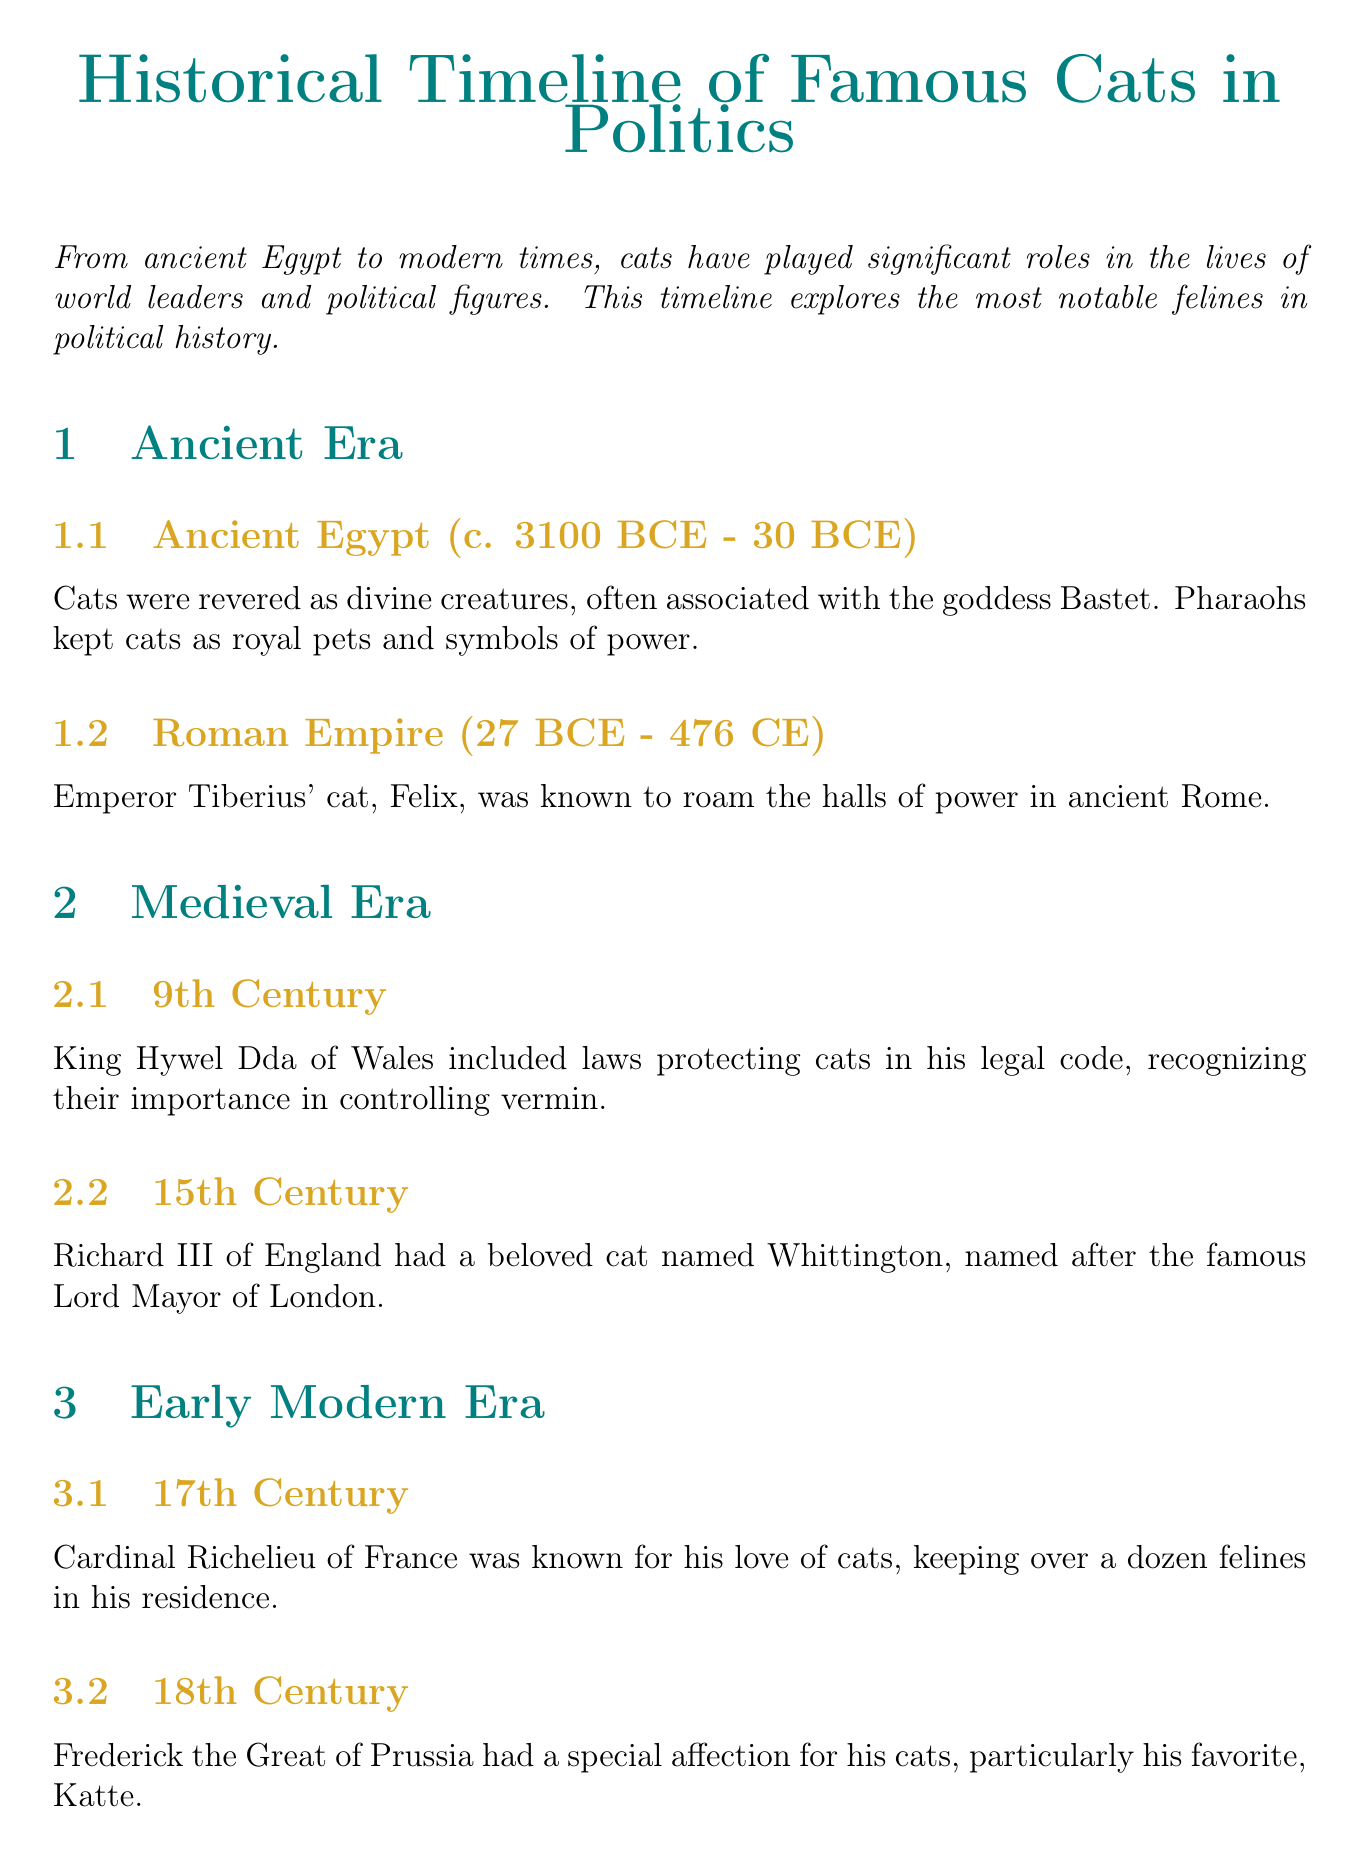What is the title of the document? The title is presented prominently at the beginning of the document.
Answer: Historical Timeline of Famous Cats in Politics Which Egyptian goddess is associated with cats? The document mentions the goddess associated with cats in ancient Egypt.
Answer: Bastet Who had a cat named Whittington? The entry provides information about a famous figure and their cat.
Answer: Richard III What was Socks Clinton known for? The document describes Socks Clinton's significance in the White House.
Answer: Most famous White House cat In what century did Frederick the Great have a favorite cat? The timeline specifies the century in which Frederick the Great's affection for cats is noted.
Answer: 18th Century What is the title of Larry's position? The document specifies Larry's official title related to his role at 10 Downing Street.
Answer: Chief Mouser to the Cabinet Office How long did Stubbs serve as mayor? The document provides duration information about Stubbs' term.
Answer: 20 years Which world leader is associated with the cat Nemo? The document mentions this specific world leader in relation to their cat.
Answer: Winston Churchill 